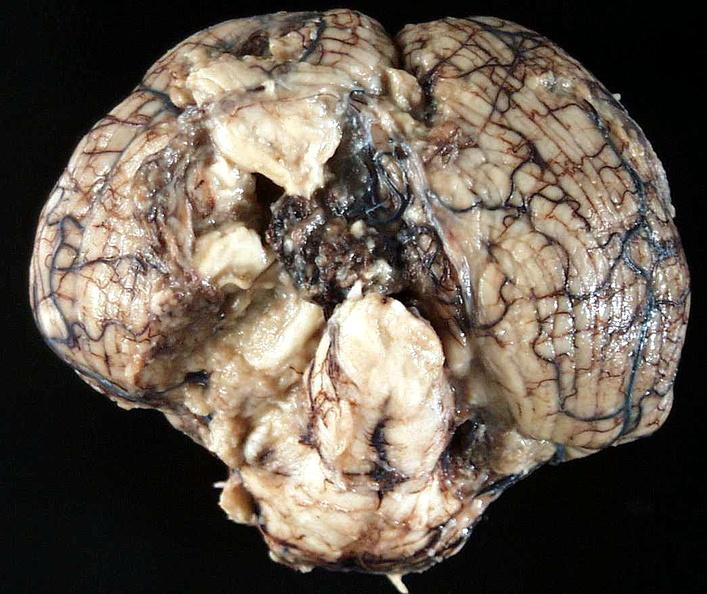what is present?
Answer the question using a single word or phrase. Nervous 